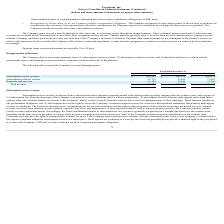According to Proofpoint's financial document, When is revenue being recognised by the company? when control of the services or products are transferred to the customers, in an amount that reflects the consideration the Company expects to be entitled to in exchange for those services or products. The document states: "mance obligation - The Company recognizes revenue when control of the services or products are transferred to the customers, in an amount that reflect..." Also, What method is used to measure the progression of how the company transfer its control? According to the financial document, time-elapsed method. The relevant text states: "updates, upgrades, bug fixes, and maintenance. A time-elapsed method is used to measure progress because the Company transfers control evenly over the contractual perio updates, upgrades, bug fixes, a..." Also, What does support revenue consists of?  ongoing security updates, upgrades, bug fixes, and maintenance. The document states: "hosted services. Support revenue is derived from ongoing security updates, upgrades, bug fixes, and maintenance. A time-elapsed method is used to meas..." Also, can you calculate: What percentage is the total revenue is from Hardware and services in year 2019? Based on the calculation: 13,184 / 888,190, the result is 1.48 (percentage). This is based on the information: "Hardware and services 13,184 12,594 13,326 Total revenue $ 888,190 $ 716,994 $ 519,681..." The key data points involved are: 13,184, 888,190. Also, can you calculate: How many percent did the revenue increase from the year 2017 to 2018? To answer this question, I need to perform calculations using the financial data. The calculation is: (716,994 - 519,681) /519,681, which equals 37.97 (percentage). This is based on the information: "Total revenue $ 888,190 $ 716,994 $ 519,681 Total revenue $ 888,190 $ 716,994 $ 519,681..." The key data points involved are: 519,681, 716,994. Also, can you calculate: How much did Subscription service revenue increase from the year 2018 to 2019? Based on the calculation: 849,267 - 681,138, the result is 168129 (in thousands). This is based on the information: "Subscription service revenue $ 849,267 $ 681,138 $ 489,274 Subscription service revenue $ 849,267 $ 681,138 $ 489,274..." The key data points involved are: 681,138, 849,267. 